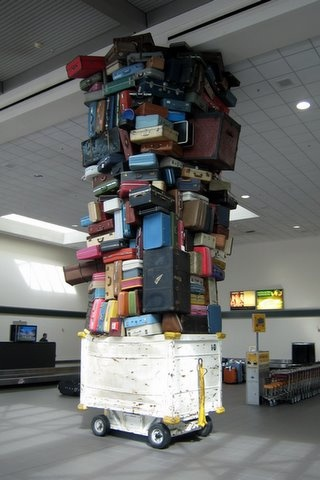Describe the objects in this image and their specific colors. I can see suitcase in black, gray, blue, and maroon tones, suitcase in black and gray tones, suitcase in black, blue, and gray tones, suitcase in black, purple, blue, and darkgray tones, and suitcase in black and gray tones in this image. 